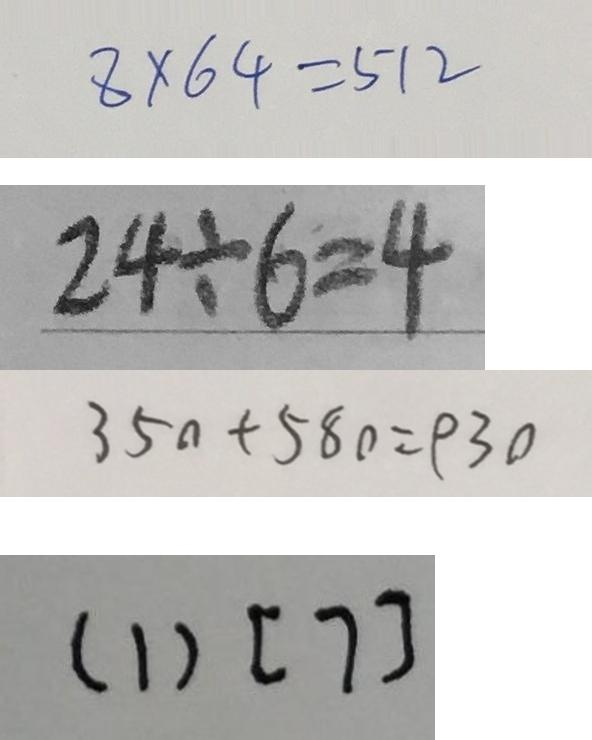Convert formula to latex. <formula><loc_0><loc_0><loc_500><loc_500>8 \times 6 4 = 5 1 2 
 2 4 \div 6 = 4 
 3 5 0 + 5 8 0 = 9 3 0 
 ( 1 ) [ 7 ]</formula> 